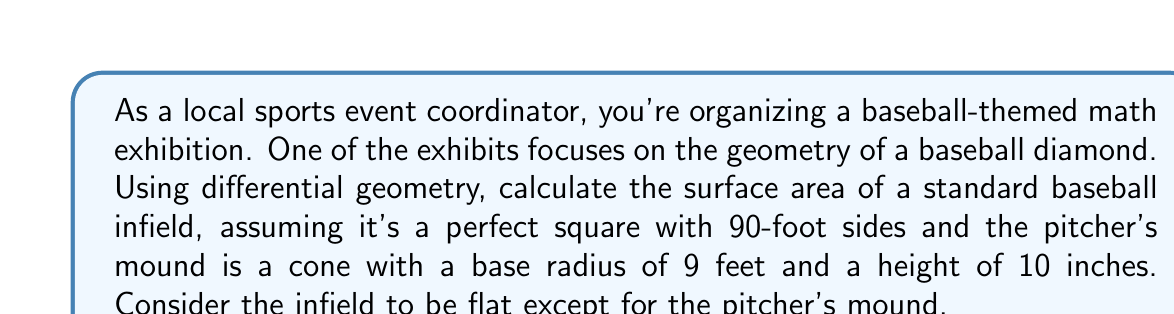Help me with this question. To solve this problem, we'll break it down into steps using differential geometry concepts:

1. Calculate the area of the flat square infield:
   The area of a square is simply the side length squared.
   $$A_{square} = 90^2 = 8100 \text{ sq ft}$$

2. Calculate the surface area of the pitcher's mound (cone):
   We'll use the formula for the lateral surface area of a cone:
   $$A_{cone} = \pi r \sqrt{r^2 + h^2}$$
   where $r$ is the radius of the base and $h$ is the height.

   Convert height to feet: $10 \text{ inches} = \frac{10}{12} \text{ ft} = \frac{5}{6} \text{ ft}$

   $$A_{cone} = \pi \cdot 9 \cdot \sqrt{9^2 + (\frac{5}{6})^2}$$
   $$A_{cone} = 9\pi \sqrt{81 + \frac{25}{36}}$$
   $$A_{cone} = 9\pi \sqrt{\frac{2916 + 25}{36}}$$
   $$A_{cone} = 9\pi \sqrt{\frac{2941}{36}}$$
   $$A_{cone} \approx 254.47 \text{ sq ft}$$

3. Calculate the area of the circular base of the cone:
   $$A_{base} = \pi r^2 = \pi \cdot 9^2 = 81\pi \approx 254.47 \text{ sq ft}$$

4. To get the total surface area, we need to:
   a. Subtract the area of the circular base from the square infield
   b. Add the surface area of the cone

   $$A_{total} = A_{square} - A_{base} + A_{cone}$$
   $$A_{total} = 8100 - 81\pi + 9\pi \sqrt{\frac{2941}{36}}$$
   $$A_{total} = 8100 + \pi(9\sqrt{\frac{2941}{36}} - 81)$$
   $$A_{total} \approx 8100 \text{ sq ft}$$

The result is approximately equal to the original square area because the cone's surface area is very close to the area of its circular base, effectively canceling out in the calculation.
Answer: The surface area of the baseball infield, including the pitcher's mound, is approximately 8100 square feet. 